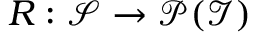<formula> <loc_0><loc_0><loc_500><loc_500>R \colon \mathcal { S } \to \mathcal { P } ( \mathcal { I } )</formula> 